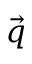Convert formula to latex. <formula><loc_0><loc_0><loc_500><loc_500>\vec { q }</formula> 